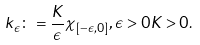<formula> <loc_0><loc_0><loc_500><loc_500>k _ { \epsilon } \colon = \frac { K } { \epsilon } \chi _ { [ - \epsilon , 0 ] } , \epsilon > 0 K > 0 .</formula> 